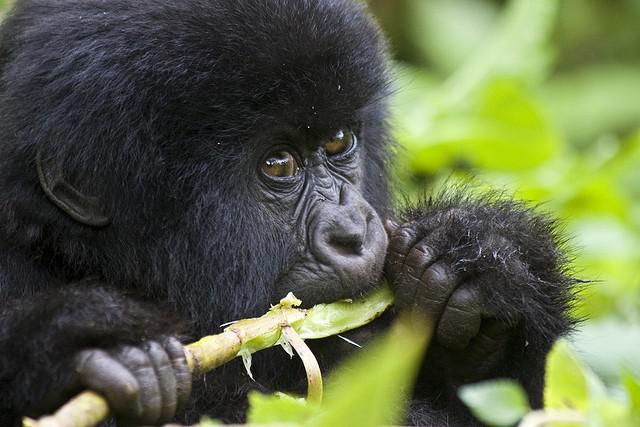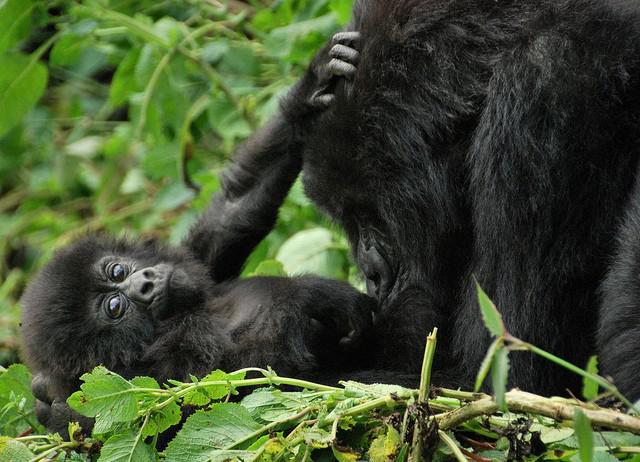The first image is the image on the left, the second image is the image on the right. For the images displayed, is the sentence "One image has a young ape along with an adult." factually correct? Answer yes or no. Yes. The first image is the image on the left, the second image is the image on the right. Examine the images to the left and right. Is the description "There is a baby primate with an adult primate." accurate? Answer yes or no. Yes. 